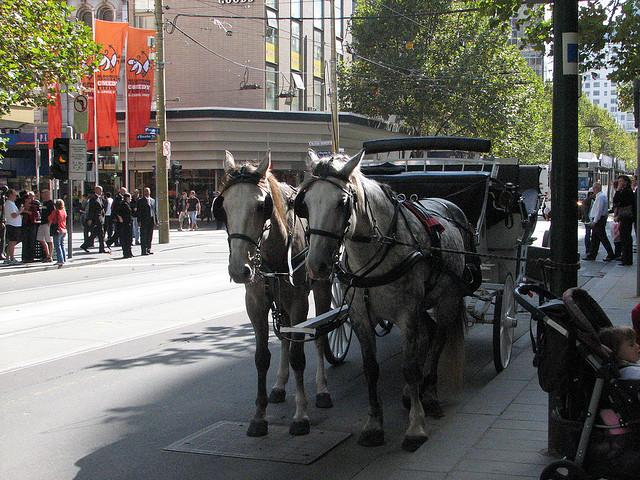What turn is forbidden?

Choices:
A) u-turn
B) right turn
C) left turn
D) straightaway left turn 